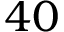<formula> <loc_0><loc_0><loc_500><loc_500>4 0</formula> 